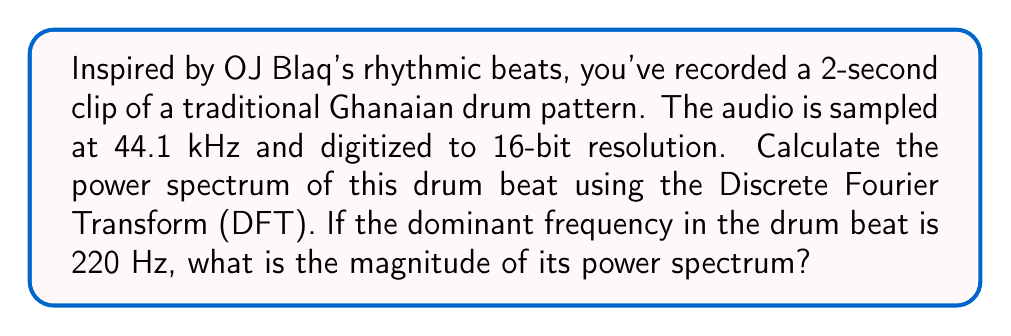Can you answer this question? Let's approach this step-by-step:

1) First, we need to determine the number of samples in our signal:
   $N = \text{duration} \times \text{sampling rate} = 2 \text{ s} \times 44100 \text{ Hz} = 88200 \text{ samples}$

2) The Discrete Fourier Transform (DFT) of a signal $x[n]$ is given by:

   $X[k] = \sum_{n=0}^{N-1} x[n] e^{-j2\pi kn/N}$

   where $k = 0, 1, ..., N-1$

3) The power spectrum is calculated as the squared magnitude of the DFT:

   $P[k] = |X[k]|^2$

4) The frequency resolution of the DFT is given by:

   $\Delta f = \frac{f_s}{N} = \frac{44100 \text{ Hz}}{88200} = 0.5 \text{ Hz}$

5) To find the bin corresponding to 220 Hz:

   $k_{220} = \frac{220 \text{ Hz}}{0.5 \text{ Hz/bin}} = 440$

6) The magnitude of the power spectrum at 220 Hz would be $P[440]$.

7) To get the exact value, we would need to perform the DFT on the actual signal data and calculate $|X[440]|^2$. However, without the actual signal data, we can't provide a numerical answer.

8) It's worth noting that in practice, we would typically use the Fast Fourier Transform (FFT) algorithm to compute the DFT efficiently, especially for large N.
Answer: The magnitude of the power spectrum at 220 Hz is $P[440] = |X[440]|^2$, where $X[440]$ is the 440th component of the DFT of the drum beat signal. The exact numerical value cannot be determined without the actual signal data. 